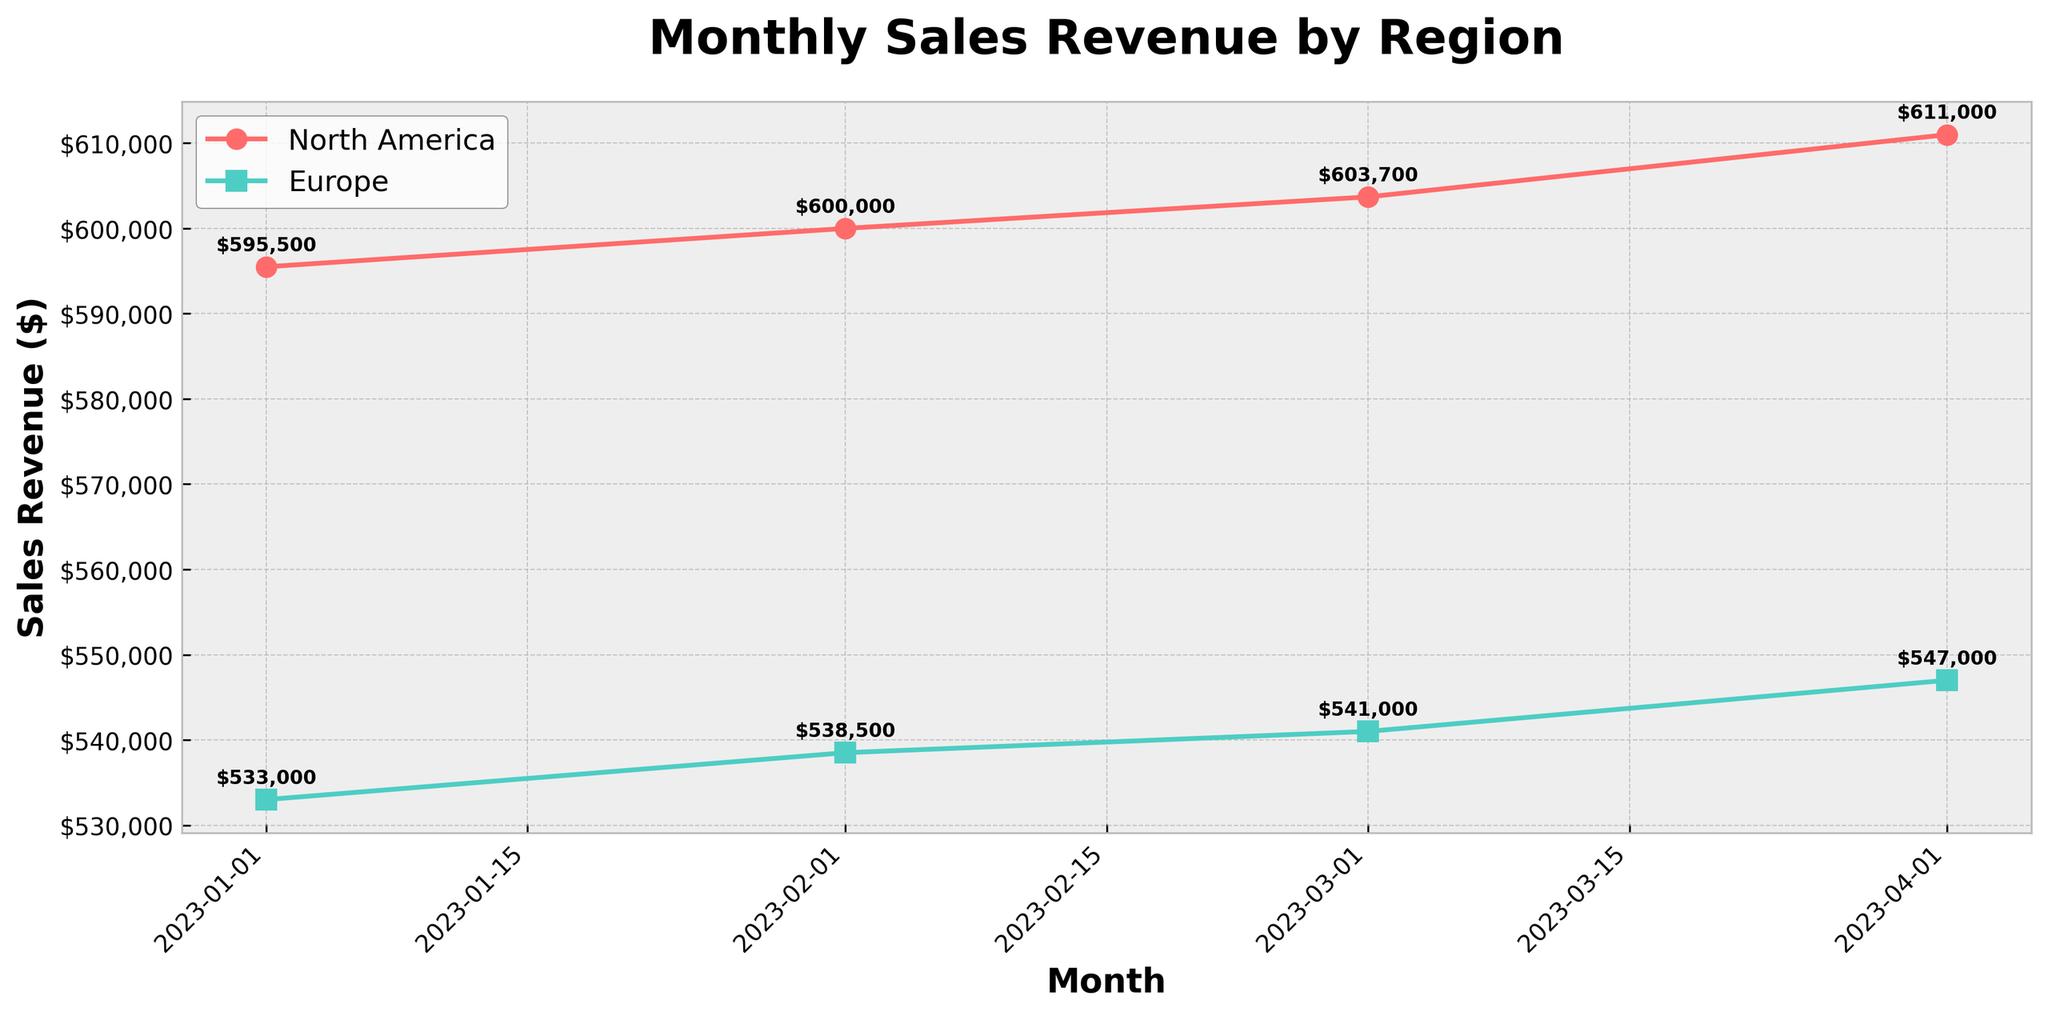What is the title of the plot? The title of the plot is positioned at the top and prominently displayed in bold. From the provided code, it is set using the `ax.set_title` method.
Answer: Monthly Sales Revenue by Region What are the different regions represented in the plot? The regions are differentiated by lines on the plot. The colors and labels of the lines help identify them. From the code, the two regions are North America and Europe.
Answer: North America and Europe What is the sales revenue for North America in April 2023? To find this, locate the April 2023 point on the x-axis and follow the North America line (marked by color or symbol) to its y-axis value. The code annotates values, making it easily readable.
Answer: $498,000 Which region had the highest sales revenue in February 2023? Locate February 2023 on the x-axis, then compare the y-axis values (annotated with data labels) for North America and Europe. The region with the higher value had the highest sales revenue.
Answer: North America By how much did the sales revenue in Europe increase from January to March 2023? Reference the sales revenue in January and March 2023 for Europe from their annotated values. Subtract January's revenue from March's revenue to get the increase.
Answer: $12,000 What is the trend of sales revenue for North America from January to April 2023? Observe the direction and slope of the North America line from January to April. A consistent upward or downward slope indicates the trend.
Answer: Upward trend Compare the sales revenue growth rate between North America and Europe from January to February 2023. Calculate the growth rate by subtracting January's revenue from February's for both regions. Then compare the two differences.
Answer: North America had a higher growth rate What was the percentage increase in sales revenue for North America from January to March 2023? Calculate the difference in sales revenue between March and January for North America. Divide by January's revenue to find the percentage increase. Formula: ((March - January) / January) * 100.
Answer: 5.33% 